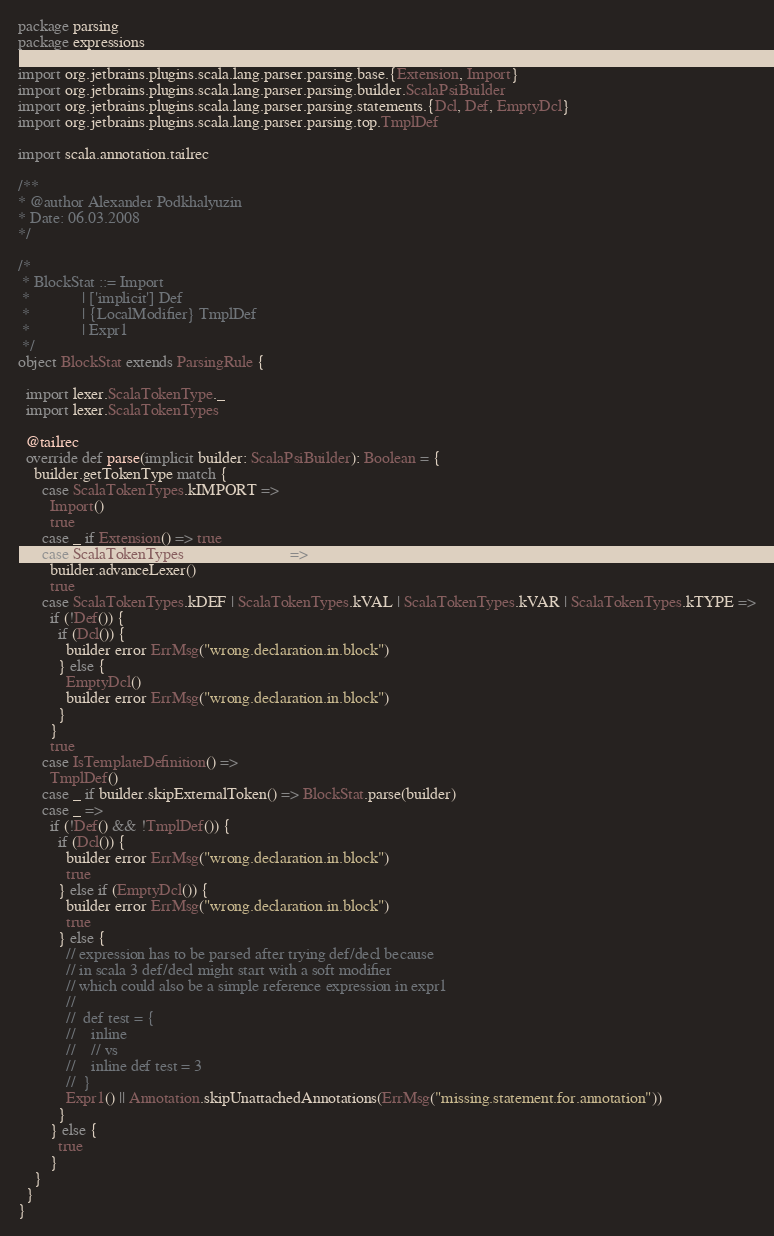Convert code to text. <code><loc_0><loc_0><loc_500><loc_500><_Scala_>package parsing
package expressions

import org.jetbrains.plugins.scala.lang.parser.parsing.base.{Extension, Import}
import org.jetbrains.plugins.scala.lang.parser.parsing.builder.ScalaPsiBuilder
import org.jetbrains.plugins.scala.lang.parser.parsing.statements.{Dcl, Def, EmptyDcl}
import org.jetbrains.plugins.scala.lang.parser.parsing.top.TmplDef

import scala.annotation.tailrec

/**
* @author Alexander Podkhalyuzin
* Date: 06.03.2008
*/

/*
 * BlockStat ::= Import
 *             | ['implicit'] Def
 *             | {LocalModifier} TmplDef
 *             | Expr1
 */
object BlockStat extends ParsingRule {

  import lexer.ScalaTokenType._
  import lexer.ScalaTokenTypes

  @tailrec
  override def parse(implicit builder: ScalaPsiBuilder): Boolean = {
    builder.getTokenType match {
      case ScalaTokenTypes.kIMPORT =>
        Import()
        true
      case _ if Extension() => true
      case ScalaTokenTypes.tSEMICOLON =>
        builder.advanceLexer()
        true
      case ScalaTokenTypes.kDEF | ScalaTokenTypes.kVAL | ScalaTokenTypes.kVAR | ScalaTokenTypes.kTYPE =>
        if (!Def()) {
          if (Dcl()) {
            builder error ErrMsg("wrong.declaration.in.block")
          } else {
            EmptyDcl()
            builder error ErrMsg("wrong.declaration.in.block")
          }
        }
        true
      case IsTemplateDefinition() =>
        TmplDef()
      case _ if builder.skipExternalToken() => BlockStat.parse(builder)
      case _ =>
        if (!Def() && !TmplDef()) {
          if (Dcl()) {
            builder error ErrMsg("wrong.declaration.in.block")
            true
          } else if (EmptyDcl()) {
            builder error ErrMsg("wrong.declaration.in.block")
            true
          } else {
            // expression has to be parsed after trying def/decl because
            // in scala 3 def/decl might start with a soft modifier
            // which could also be a simple reference expression in expr1
            //
            //  def test = {
            //    inline
            //    // vs
            //    inline def test = 3
            //  }
            Expr1() || Annotation.skipUnattachedAnnotations(ErrMsg("missing.statement.for.annotation"))
          }
        } else {
          true
        }
    }
  }
}</code> 